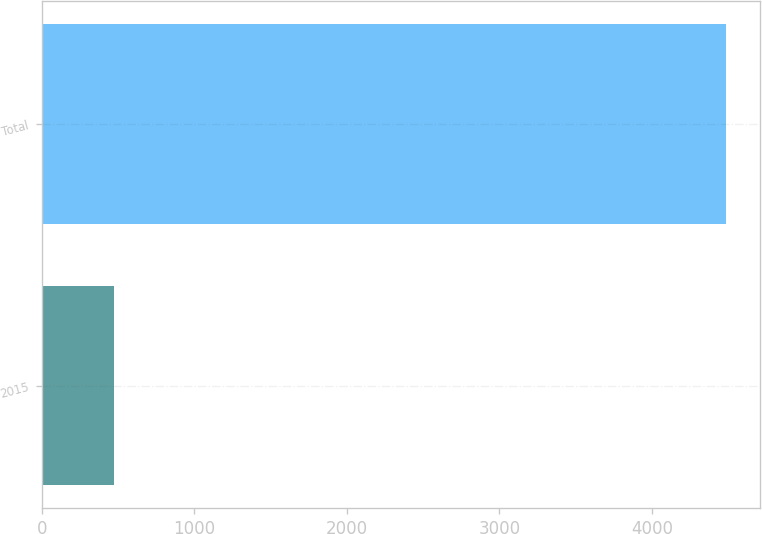Convert chart. <chart><loc_0><loc_0><loc_500><loc_500><bar_chart><fcel>2015<fcel>Total<nl><fcel>471<fcel>4486<nl></chart> 